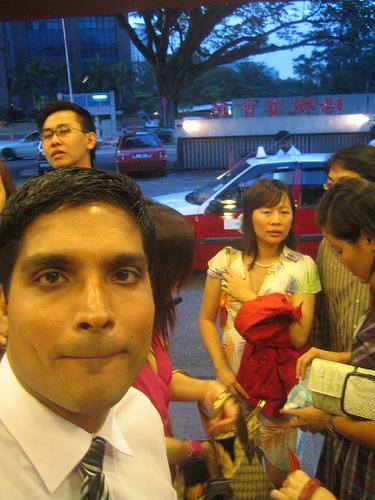What nationality does the man in the foreground appear to be? Please explain your reasoning. indian. The people are indian. 